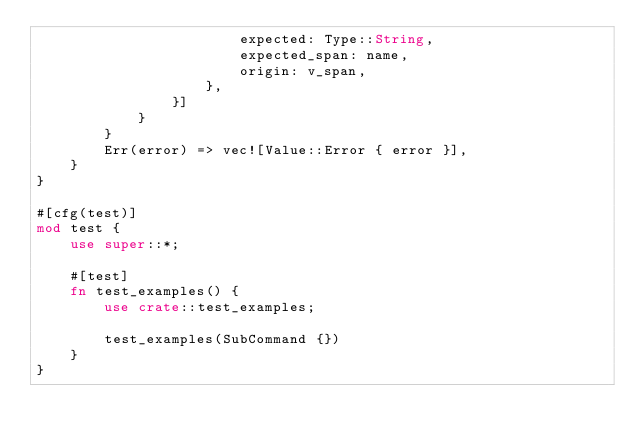<code> <loc_0><loc_0><loc_500><loc_500><_Rust_>                        expected: Type::String,
                        expected_span: name,
                        origin: v_span,
                    },
                }]
            }
        }
        Err(error) => vec![Value::Error { error }],
    }
}

#[cfg(test)]
mod test {
    use super::*;

    #[test]
    fn test_examples() {
        use crate::test_examples;

        test_examples(SubCommand {})
    }
}
</code> 